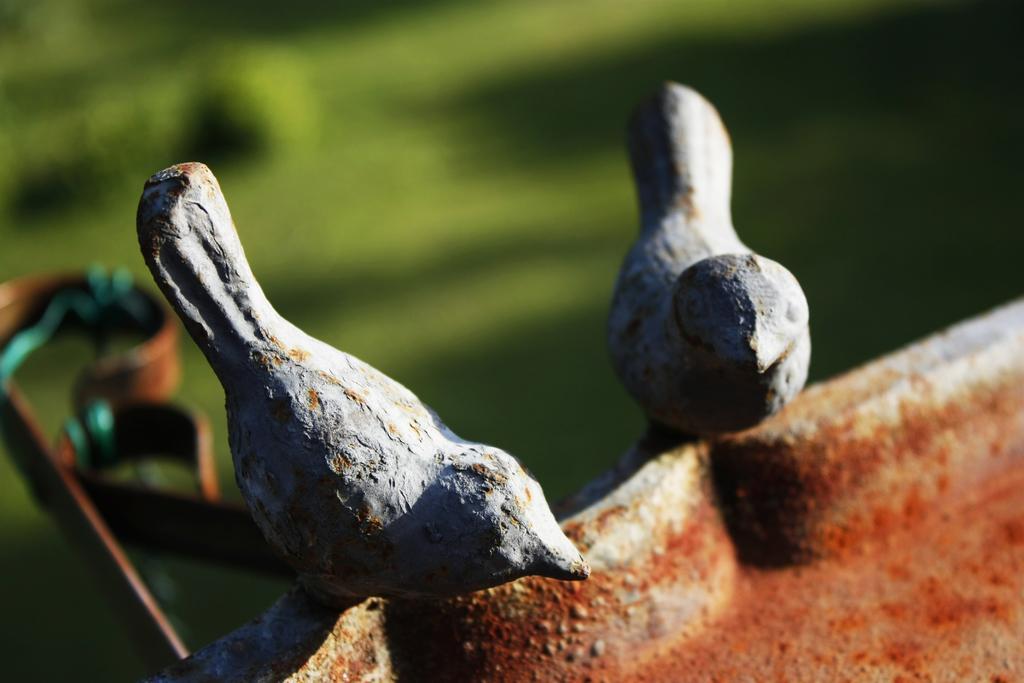Please provide a concise description of this image. In front of the image there are depictions of two birds on the rock. Behind the birds there is some object and the background of the image is blur. 